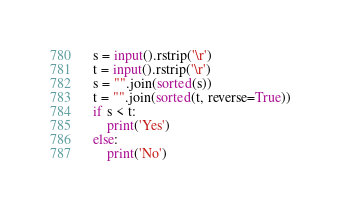<code> <loc_0><loc_0><loc_500><loc_500><_Python_>s = input().rstrip('\r')
t = input().rstrip('\r')
s = "".join(sorted(s))
t = "".join(sorted(t, reverse=True))
if s < t:
    print('Yes')
else:
    print('No')</code> 